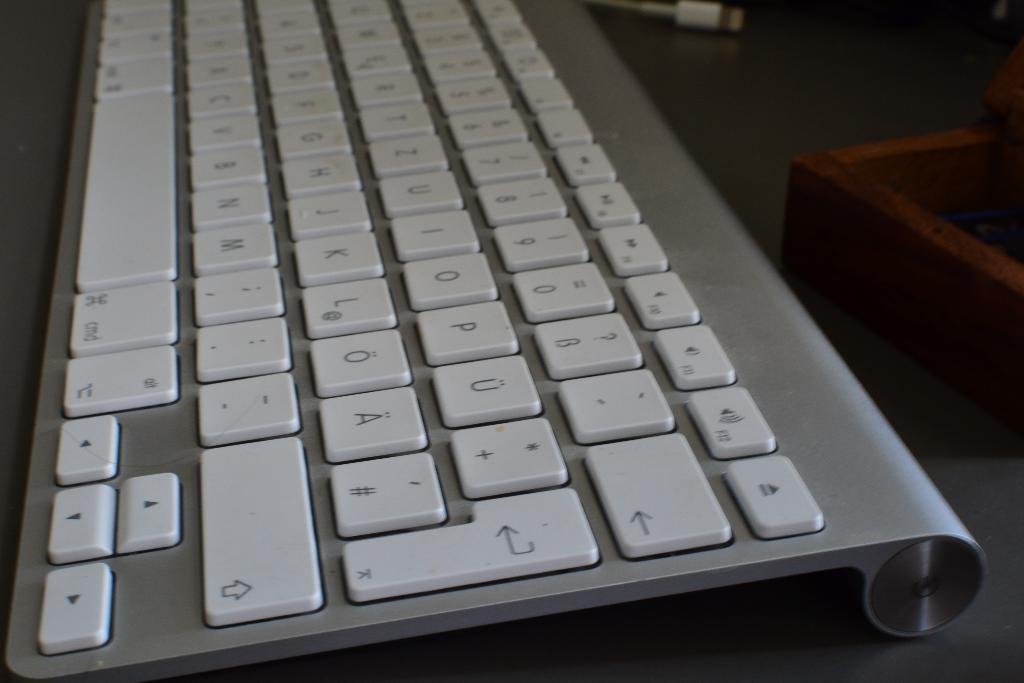<image>
Offer a succinct explanation of the picture presented. An Apple keyboard with standard cmd and eject buttons. 